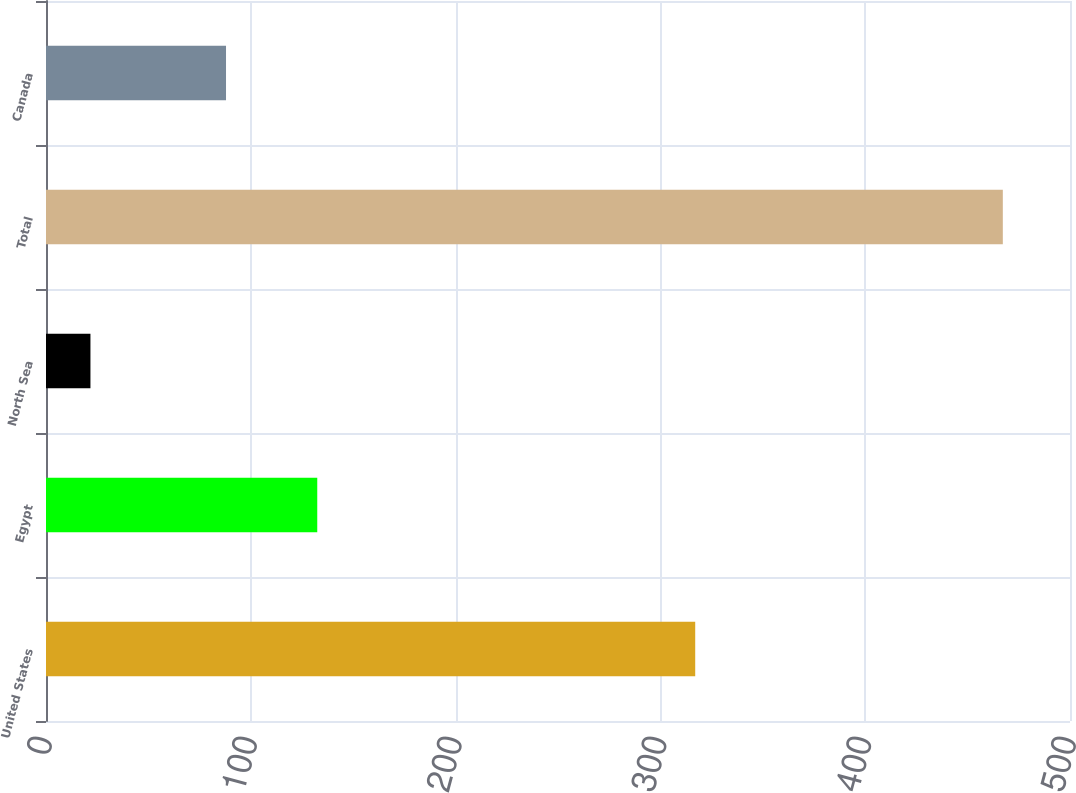Convert chart. <chart><loc_0><loc_0><loc_500><loc_500><bar_chart><fcel>United States<fcel>Egypt<fcel>North Sea<fcel>Total<fcel>Canada<nl><fcel>317<fcel>132.45<fcel>21.7<fcel>467.2<fcel>87.9<nl></chart> 